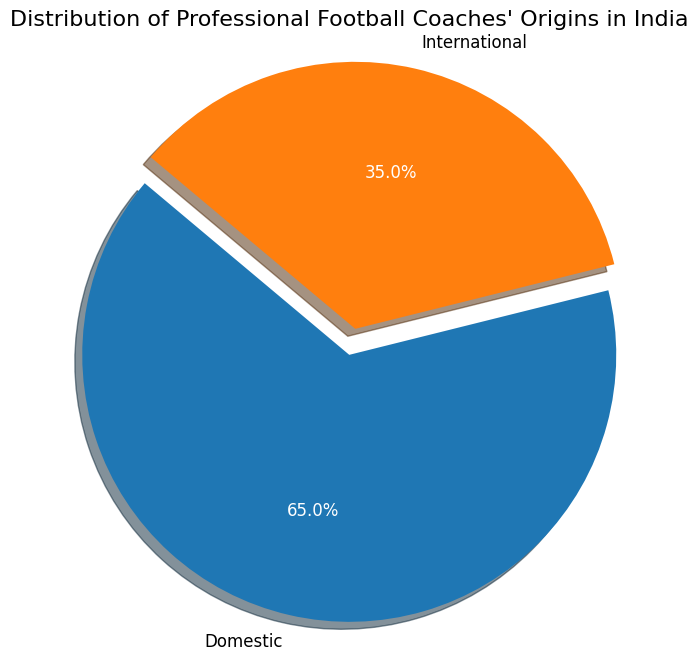What percentage of professional football coaches in India are international? According to the pie chart, the "International" section of the pie chart shows the percentage labeled directly. The label indicates that 35% of the coaches are international.
Answer: 35% What is the combined percentage of domestic and international coaches in India? The pie chart shows that there are only two sections, Domestic and International, which must sum to 100%. Domestic is 65%, and International is 35%. Adding these two percentages gives us 65% + 35% = 100%.
Answer: 100% How much larger is the percentage of domestic coaches compared to international coaches in India? According to the pie chart, Domestic coaches make up 65% while International coaches make up 35%. The difference is calculated as 65% - 35% = 30%.
Answer: 30% What is the ratio of domestic coaches to international coaches in India? From the pie chart, there are 65% domestic coaches and 35% international coaches. The ratio of domestic to international coaches is calculated as 65:35, which simplifies to 13:7.
Answer: 13:7 Which group of coaches appears larger in the pie chart and by what visual attribute can you tell? The pie chart visually represents the proportions of Domestic and International coaches. The Domestic section is larger and 'bulges' out slightly due to the explode parameter, while also occupying more of the circle compared to the International section.
Answer: Domestic, larger slice If the total number of professional football coaches in India is 200, how many are international? The pie chart indicates 35% of coaches are international. To find the number of international coaches, we calculate 35% of 200: (35/100) * 200 = 70.
Answer: 70 Based on the visual attributes, which slice of the pie chart has an exploded view and what does this represent? In the pie chart, the "Domestic" slice is exploded (separated slightly from the rest of the pie). This signifies emphasis and indicates that Domestic represents 65% of the total.
Answer: Domestic, 65% 